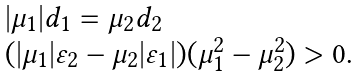Convert formula to latex. <formula><loc_0><loc_0><loc_500><loc_500>\begin{array} { l } | \mu _ { 1 } | d _ { 1 } = \mu _ { 2 } d _ { 2 } \\ ( | \mu _ { 1 } | \varepsilon _ { 2 } - \mu _ { 2 } | \varepsilon _ { 1 } | ) ( \mu _ { 1 } ^ { 2 } - \mu _ { 2 } ^ { 2 } ) > 0 . \end{array}</formula> 